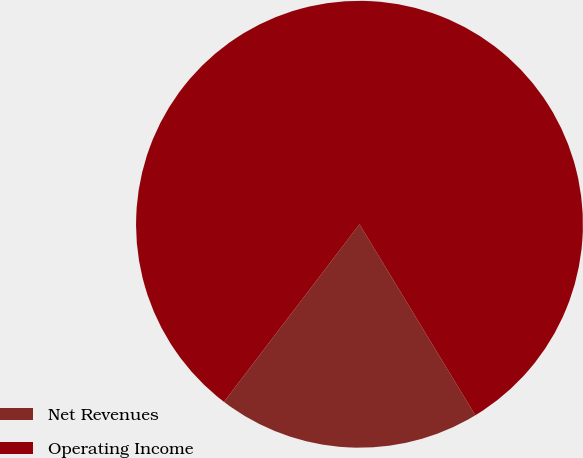Convert chart. <chart><loc_0><loc_0><loc_500><loc_500><pie_chart><fcel>Net Revenues<fcel>Operating Income<nl><fcel>19.05%<fcel>80.95%<nl></chart> 